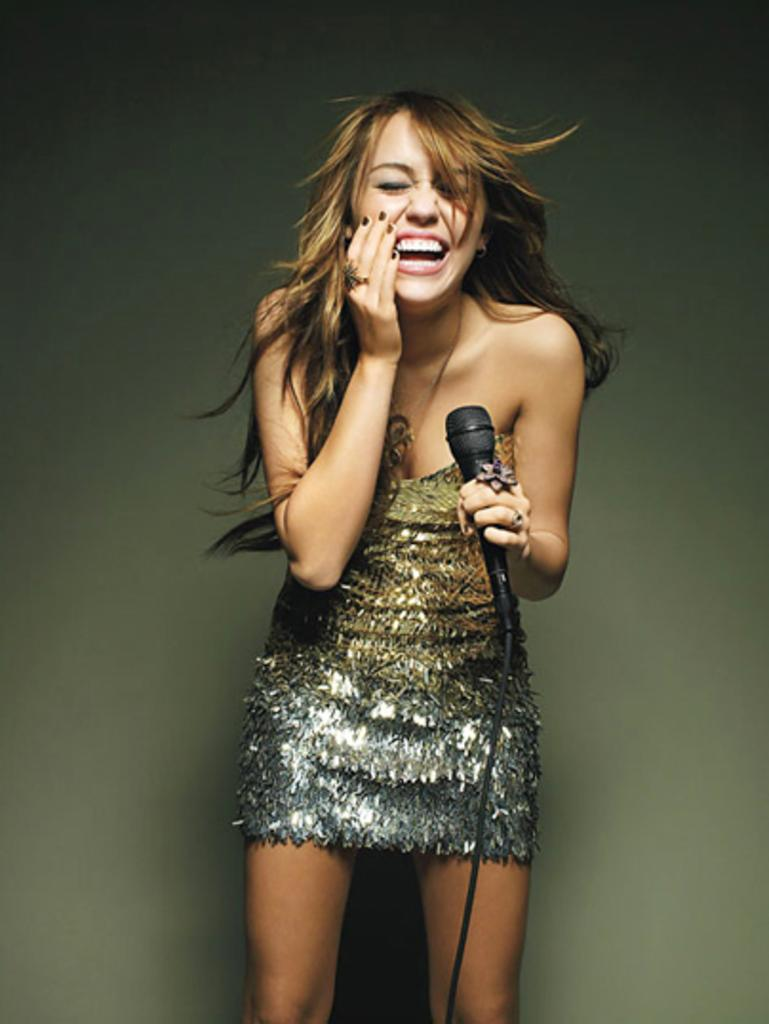Who is the main subject in the image? There is a woman in the image. What is the woman holding in the image? The woman is holding a microphone. How is the woman expressing herself in the image? The woman is laughing. What type of zebra can be seen in the image? There is no zebra present in the image. Reasoning: Let's think step by step in order to produce the conversation. We start by identifying the main subject in the image, which is the woman. Then, we describe what the woman is holding, which is a microphone. Finally, we focus on the woman's expression, noting that she is laughing. Each question is designed to elicit a specific detail about the image that is known from the provided facts. Absurd Question/Answer: How does the woman adjust the microphone in the image? The image does not show the woman adjusting the microphone; she is simply holding it. 